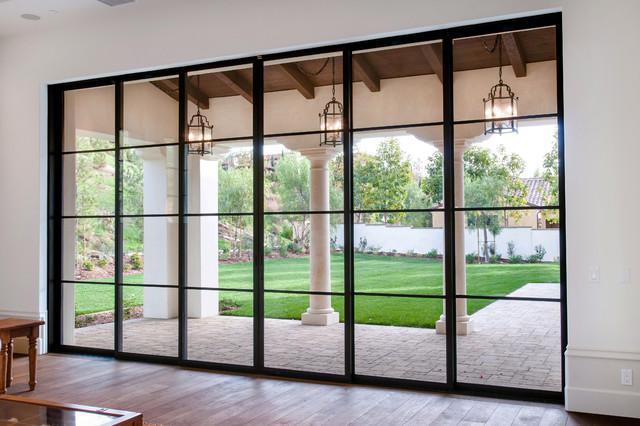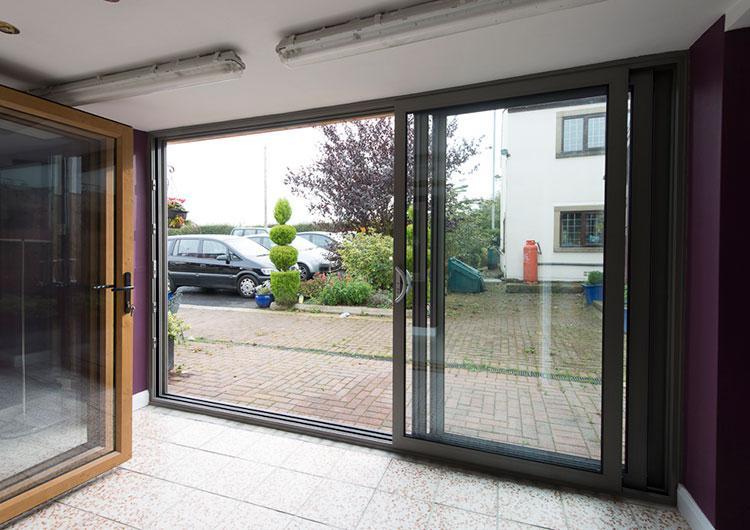The first image is the image on the left, the second image is the image on the right. For the images shown, is this caption "The doors in the image on the right open to a grassy area." true? Answer yes or no. No. The first image is the image on the left, the second image is the image on the right. For the images shown, is this caption "An image shows a sliding door unit providing an unobstructed view that is at least as wide as it is tall." true? Answer yes or no. Yes. 